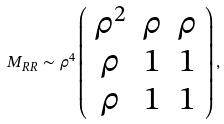<formula> <loc_0><loc_0><loc_500><loc_500>M _ { R R } \sim \rho ^ { 4 } \left ( \begin{array} { c c c } \rho ^ { 2 } & \rho & \rho \\ \rho & 1 & 1 \\ \rho & 1 & 1 \end{array} \right ) ,</formula> 